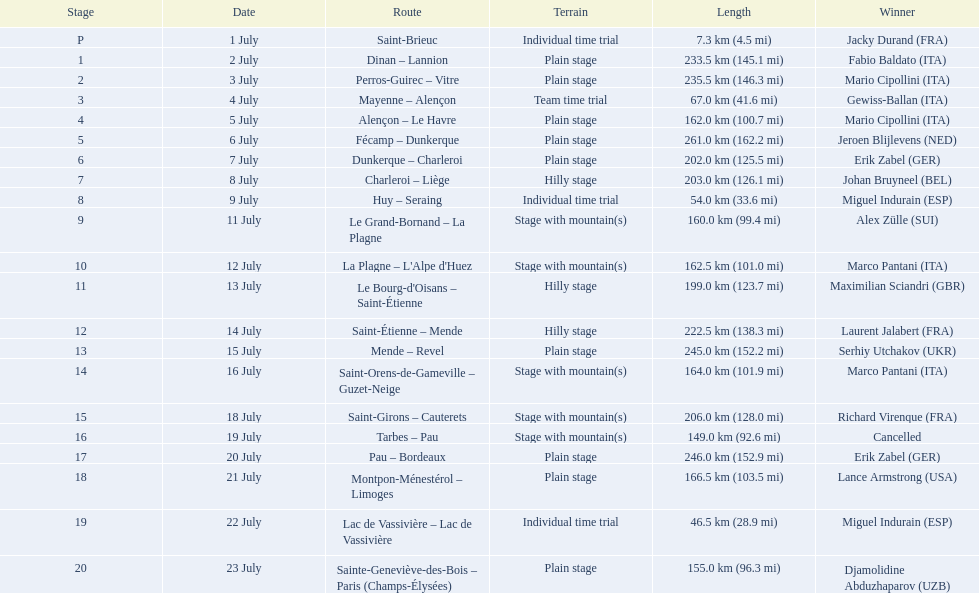How many stages were at least 200 km in length in the 1995 tour de france? 9. 